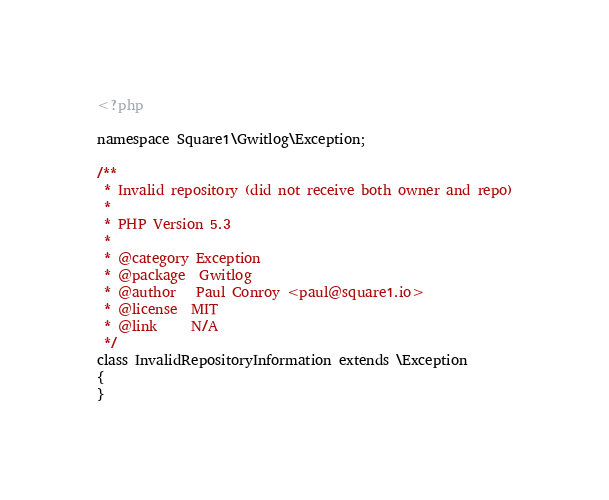Convert code to text. <code><loc_0><loc_0><loc_500><loc_500><_PHP_><?php

namespace Square1\Gwitlog\Exception;

/**
 * Invalid repository (did not receive both owner and repo)
 *
 * PHP Version 5.3
 *
 * @category Exception
 * @package  Gwitlog
 * @author   Paul Conroy <paul@square1.io>
 * @license  MIT
 * @link     N/A
 */
class InvalidRepositoryInformation extends \Exception
{
}
</code> 